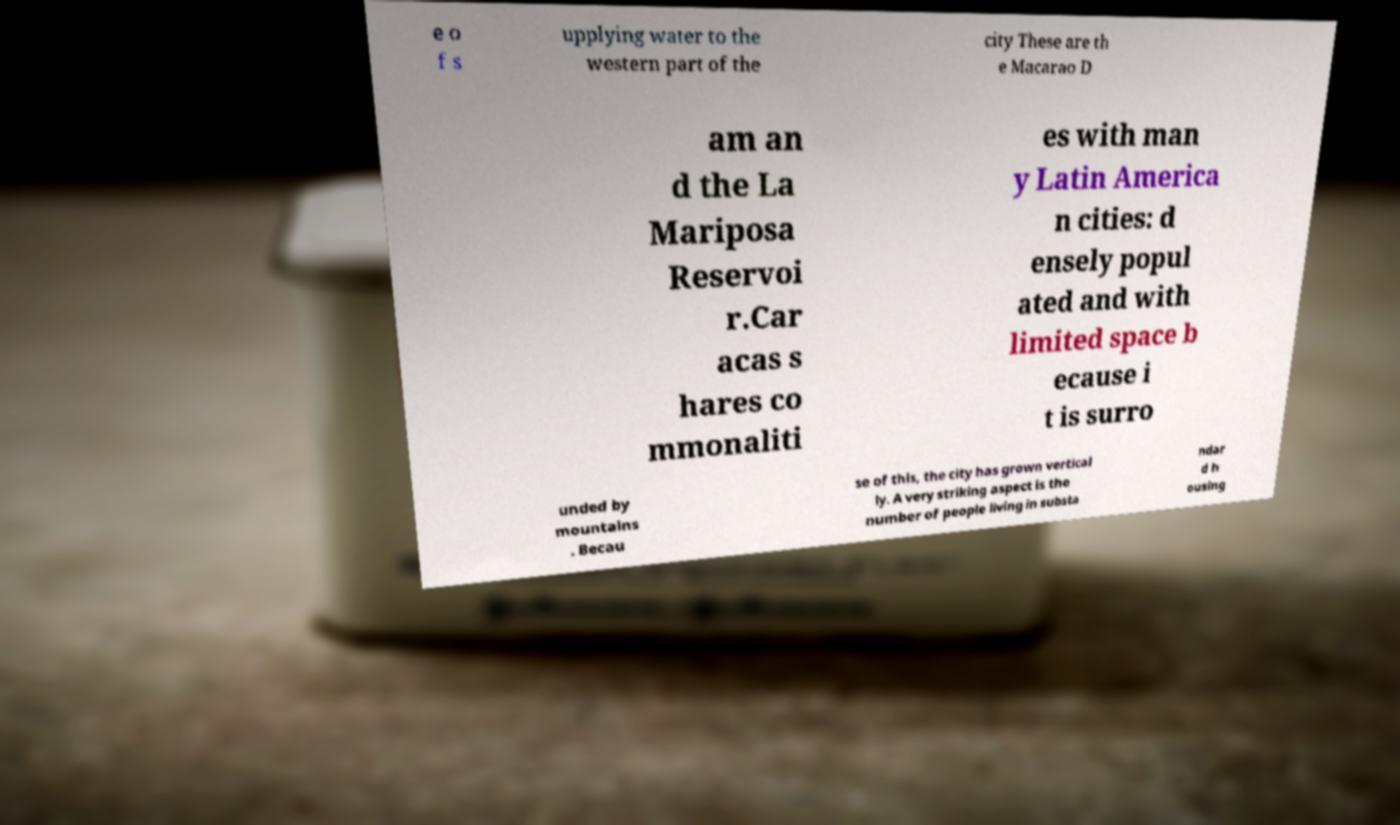Please read and relay the text visible in this image. What does it say? e o f s upplying water to the western part of the city These are th e Macarao D am an d the La Mariposa Reservoi r.Car acas s hares co mmonaliti es with man y Latin America n cities: d ensely popul ated and with limited space b ecause i t is surro unded by mountains . Becau se of this, the city has grown vertical ly. A very striking aspect is the number of people living in substa ndar d h ousing 